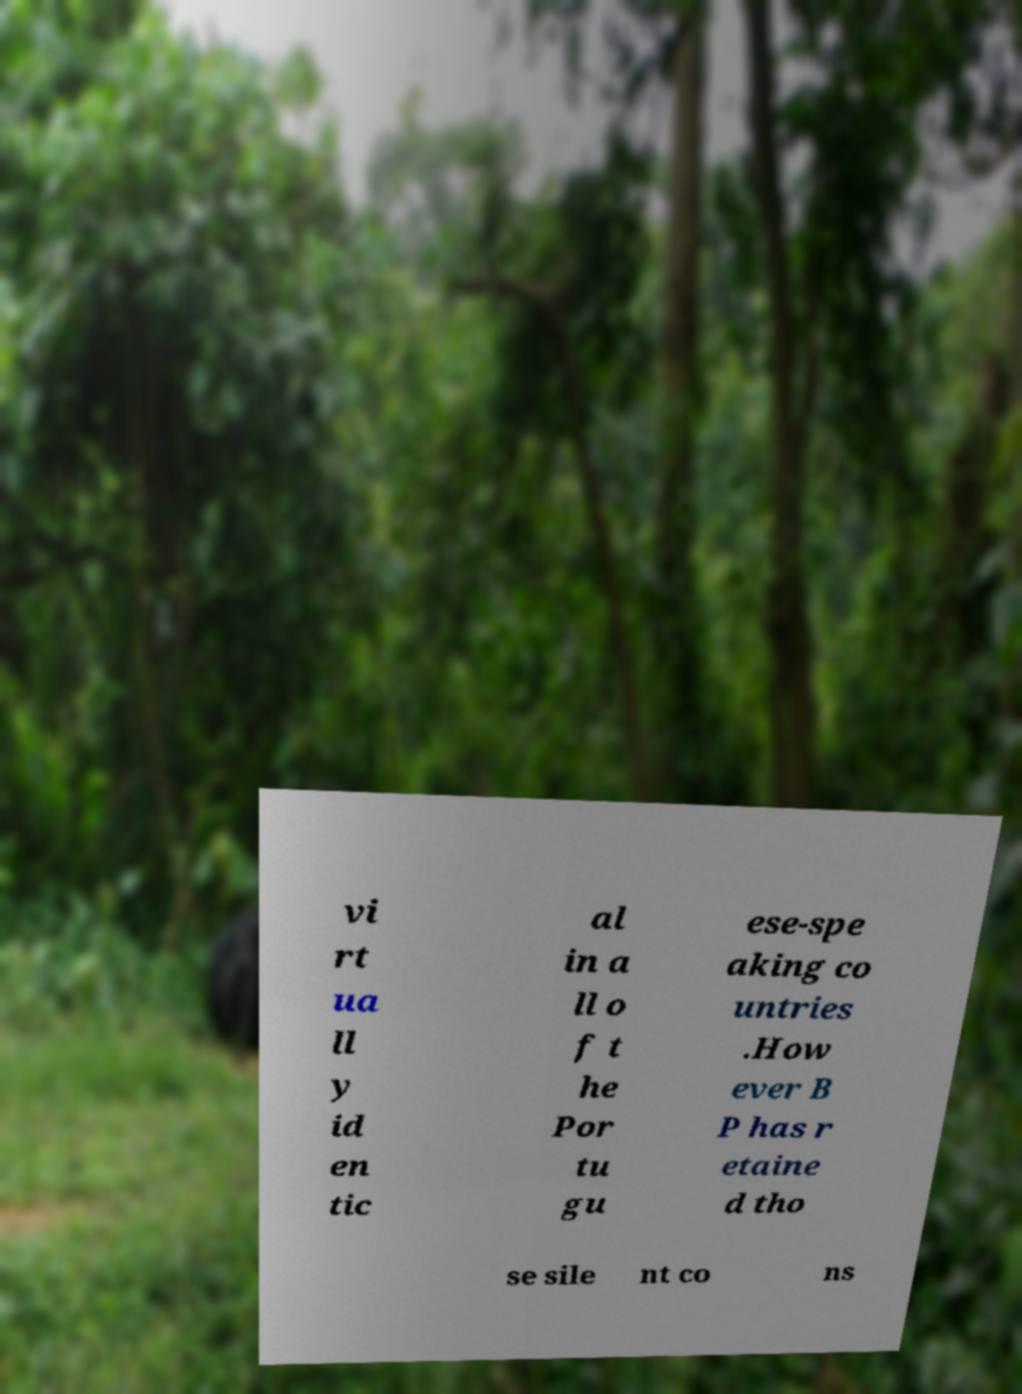Could you extract and type out the text from this image? vi rt ua ll y id en tic al in a ll o f t he Por tu gu ese-spe aking co untries .How ever B P has r etaine d tho se sile nt co ns 